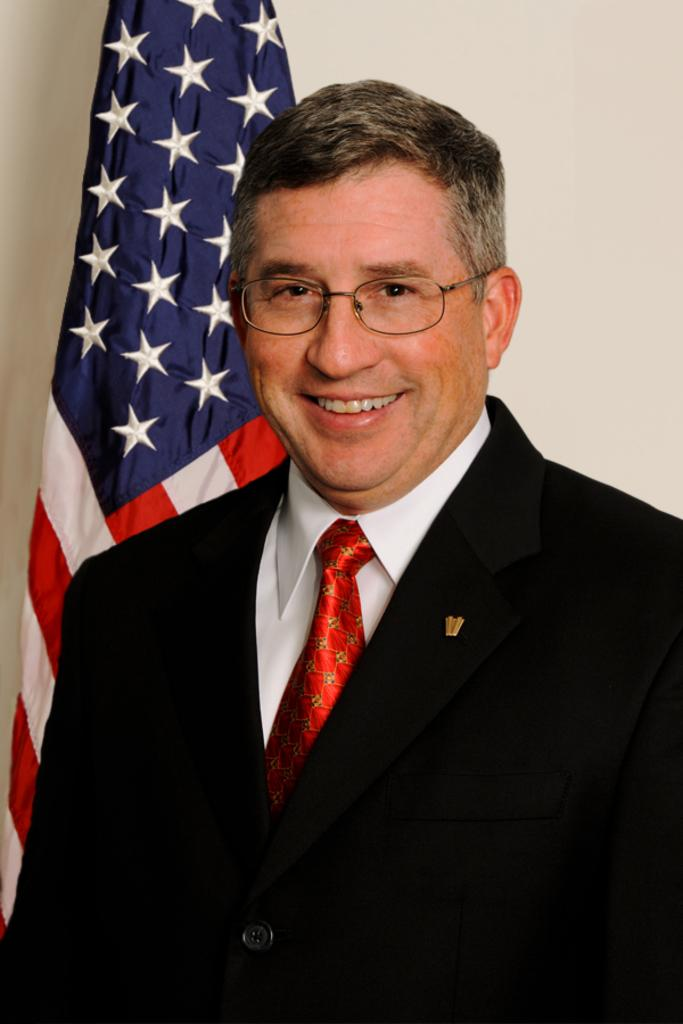What is the main subject of the image? There is a person in the image. What type of clothing is the person wearing? The person is wearing a blazer, a shirt, and a tie. What can be seen in the background of the image? There is a flag and a wall in the background of the image. What type of fiction can be seen in the zoo enclosures in the image? There is no fiction or zoo present in the image; it features a person wearing a blazer, shirt, and tie with a flag and wall in the background. 